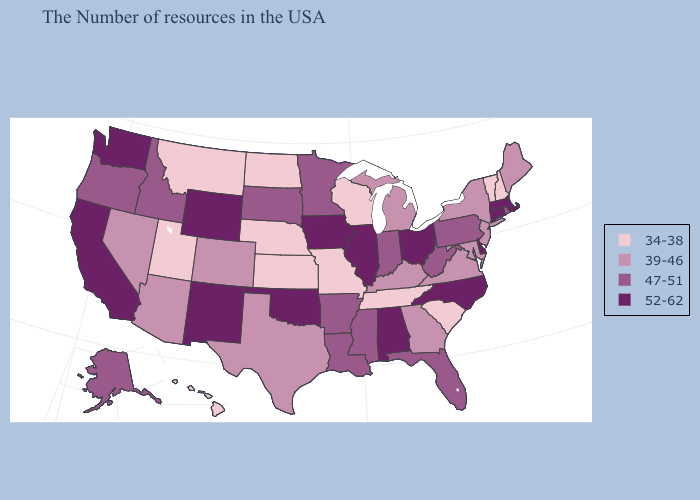Does Hawaii have the lowest value in the USA?
Be succinct. Yes. Does Connecticut have the lowest value in the USA?
Concise answer only. No. What is the highest value in states that border South Dakota?
Write a very short answer. 52-62. Does Texas have the lowest value in the South?
Be succinct. No. Which states have the highest value in the USA?
Short answer required. Massachusetts, Connecticut, Delaware, North Carolina, Ohio, Alabama, Illinois, Iowa, Oklahoma, Wyoming, New Mexico, California, Washington. Name the states that have a value in the range 52-62?
Give a very brief answer. Massachusetts, Connecticut, Delaware, North Carolina, Ohio, Alabama, Illinois, Iowa, Oklahoma, Wyoming, New Mexico, California, Washington. What is the value of Mississippi?
Quick response, please. 47-51. Name the states that have a value in the range 52-62?
Give a very brief answer. Massachusetts, Connecticut, Delaware, North Carolina, Ohio, Alabama, Illinois, Iowa, Oklahoma, Wyoming, New Mexico, California, Washington. Among the states that border New York , does Connecticut have the lowest value?
Be succinct. No. Which states have the lowest value in the South?
Answer briefly. South Carolina, Tennessee. Does Illinois have the highest value in the USA?
Short answer required. Yes. Does Wisconsin have the lowest value in the USA?
Concise answer only. Yes. What is the value of Massachusetts?
Be succinct. 52-62. Does Arkansas have a higher value than Tennessee?
Keep it brief. Yes. 